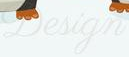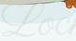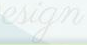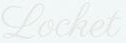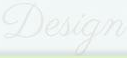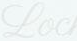Transcribe the words shown in these images in order, separated by a semicolon. Design; Loc; esign; Locket; Design; Loc 